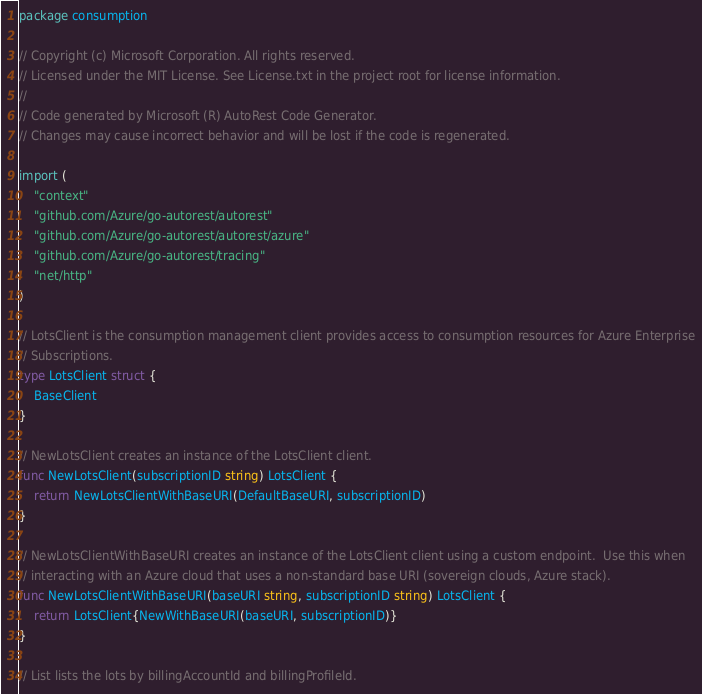Convert code to text. <code><loc_0><loc_0><loc_500><loc_500><_Go_>package consumption

// Copyright (c) Microsoft Corporation. All rights reserved.
// Licensed under the MIT License. See License.txt in the project root for license information.
//
// Code generated by Microsoft (R) AutoRest Code Generator.
// Changes may cause incorrect behavior and will be lost if the code is regenerated.

import (
	"context"
	"github.com/Azure/go-autorest/autorest"
	"github.com/Azure/go-autorest/autorest/azure"
	"github.com/Azure/go-autorest/tracing"
	"net/http"
)

// LotsClient is the consumption management client provides access to consumption resources for Azure Enterprise
// Subscriptions.
type LotsClient struct {
	BaseClient
}

// NewLotsClient creates an instance of the LotsClient client.
func NewLotsClient(subscriptionID string) LotsClient {
	return NewLotsClientWithBaseURI(DefaultBaseURI, subscriptionID)
}

// NewLotsClientWithBaseURI creates an instance of the LotsClient client using a custom endpoint.  Use this when
// interacting with an Azure cloud that uses a non-standard base URI (sovereign clouds, Azure stack).
func NewLotsClientWithBaseURI(baseURI string, subscriptionID string) LotsClient {
	return LotsClient{NewWithBaseURI(baseURI, subscriptionID)}
}

// List lists the lots by billingAccountId and billingProfileId.</code> 